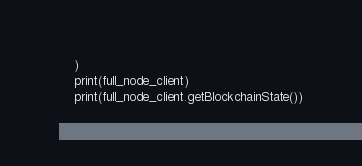<code> <loc_0><loc_0><loc_500><loc_500><_Python_>    )
    print(full_node_client)
    print(full_node_client.getBlockchainState())
</code> 